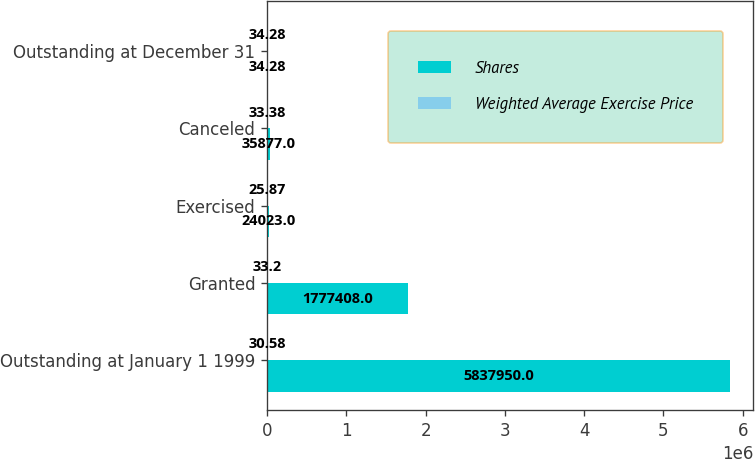Convert chart to OTSL. <chart><loc_0><loc_0><loc_500><loc_500><stacked_bar_chart><ecel><fcel>Outstanding at January 1 1999<fcel>Granted<fcel>Exercised<fcel>Canceled<fcel>Outstanding at December 31<nl><fcel>Shares<fcel>5.83795e+06<fcel>1.77741e+06<fcel>24023<fcel>35877<fcel>34.28<nl><fcel>Weighted Average Exercise Price<fcel>30.58<fcel>33.2<fcel>25.87<fcel>33.38<fcel>34.28<nl></chart> 